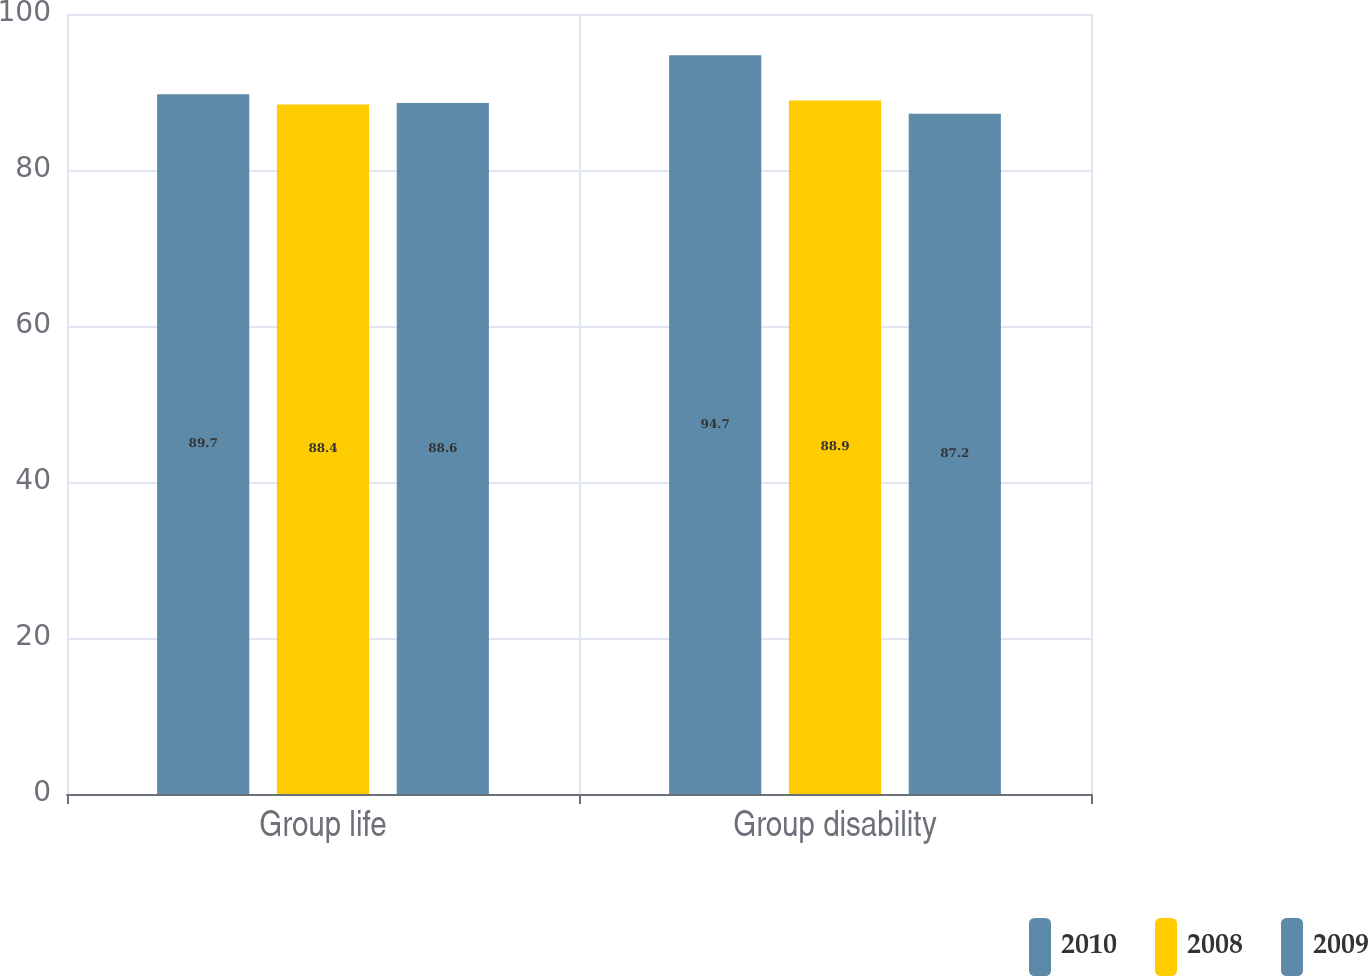<chart> <loc_0><loc_0><loc_500><loc_500><stacked_bar_chart><ecel><fcel>Group life<fcel>Group disability<nl><fcel>2010<fcel>89.7<fcel>94.7<nl><fcel>2008<fcel>88.4<fcel>88.9<nl><fcel>2009<fcel>88.6<fcel>87.2<nl></chart> 